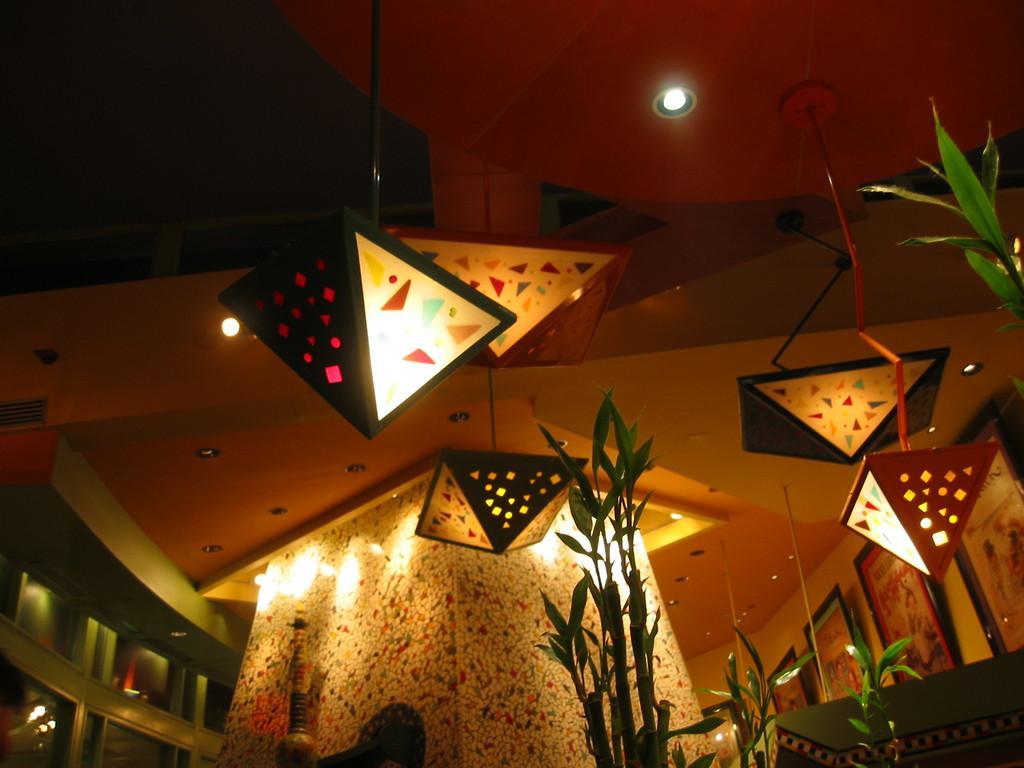Describe this image in one or two sentences. In this picture there are plants and there are frames on the wall. At the top there are lights. In the foreground there is an object. At the bottom left there is a reflection of light on the mirror. 